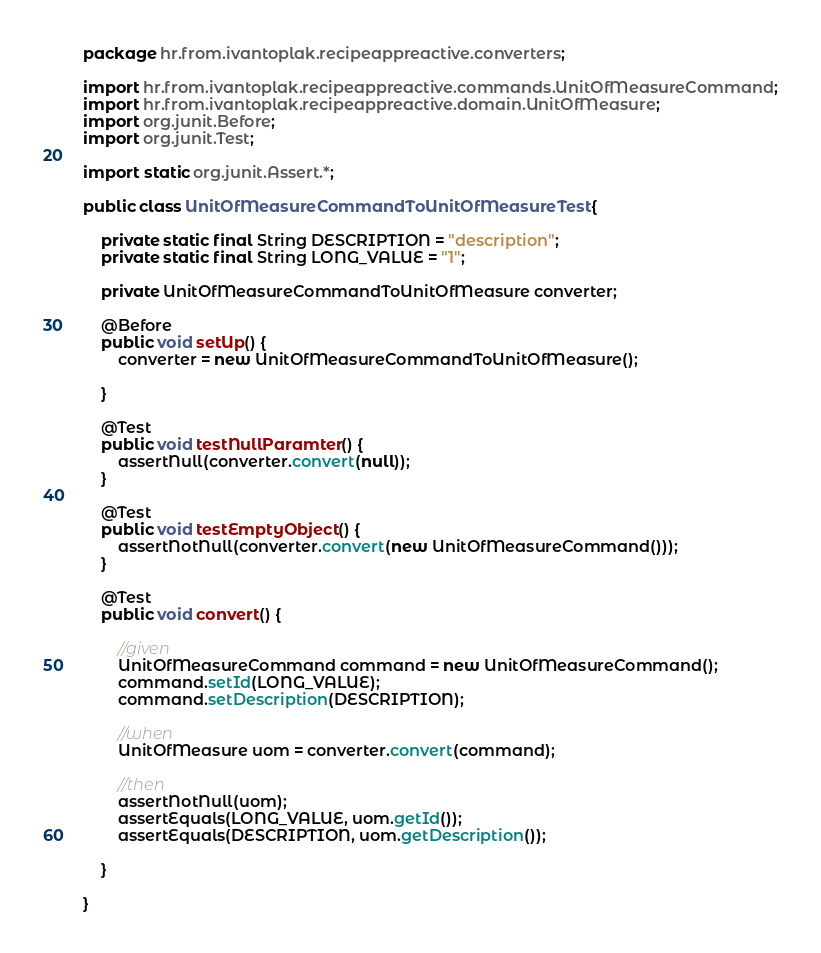<code> <loc_0><loc_0><loc_500><loc_500><_Java_>package hr.from.ivantoplak.recipeappreactive.converters;

import hr.from.ivantoplak.recipeappreactive.commands.UnitOfMeasureCommand;
import hr.from.ivantoplak.recipeappreactive.domain.UnitOfMeasure;
import org.junit.Before;
import org.junit.Test;

import static org.junit.Assert.*;

public class UnitOfMeasureCommandToUnitOfMeasureTest {

    private static final String DESCRIPTION = "description";
    private static final String LONG_VALUE = "1";

    private UnitOfMeasureCommandToUnitOfMeasure converter;

    @Before
    public void setUp() {
        converter = new UnitOfMeasureCommandToUnitOfMeasure();

    }

    @Test
    public void testNullParamter() {
        assertNull(converter.convert(null));
    }

    @Test
    public void testEmptyObject() {
        assertNotNull(converter.convert(new UnitOfMeasureCommand()));
    }

    @Test
    public void convert() {

        //given
        UnitOfMeasureCommand command = new UnitOfMeasureCommand();
        command.setId(LONG_VALUE);
        command.setDescription(DESCRIPTION);

        //when
        UnitOfMeasure uom = converter.convert(command);

        //then
        assertNotNull(uom);
        assertEquals(LONG_VALUE, uom.getId());
        assertEquals(DESCRIPTION, uom.getDescription());

    }

}</code> 